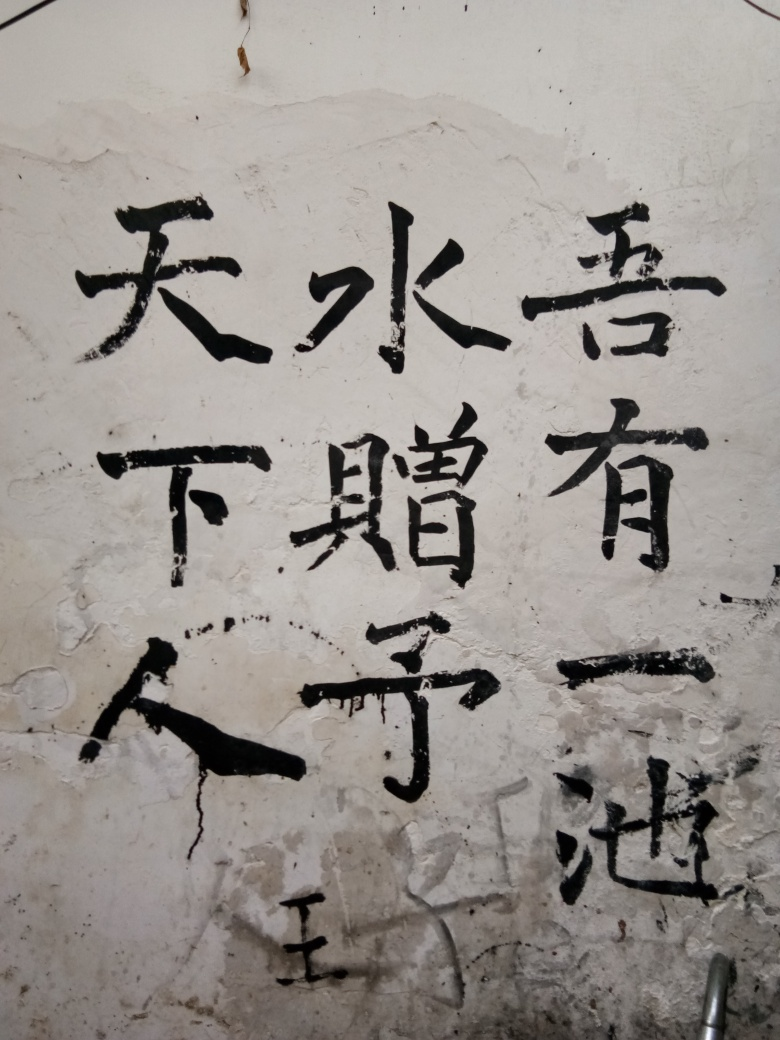How is the color rendering in the image? The image showcases a monochromatic palette, primarily displaying varying tones of black ink against a stark white background. The clearly discernible gradients from rich black to faded gray offer a raw and unpolished aesthetic. The handwritten characters possess a textured presence due to the blotting and streaking, which adds a layer of depth and authenticity to the visual presentation. 